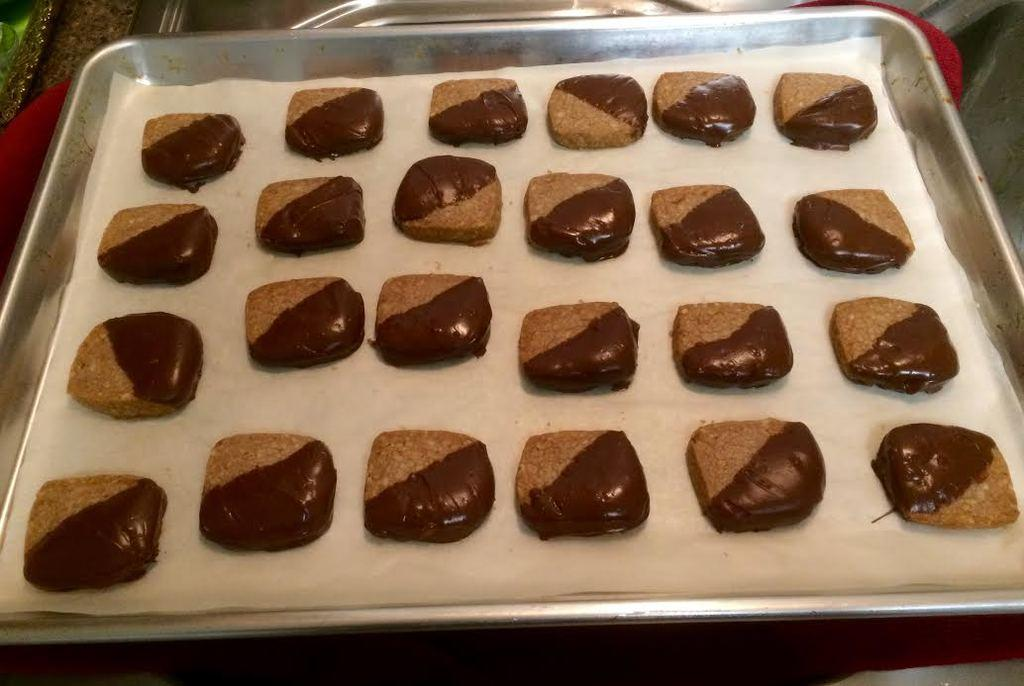What is in the center of the image? There is a plate in the center of the image. What is on the plate? There are cookies on the plate. Is there anything else on the plate besides the cookies? Yes, there is a paper on the plate. What can be seen in the background of the image? There are other objects visible in the background of the image. What type of force is being applied to the cookies on the plate? There is no indication of any force being applied to the cookies in the image. 